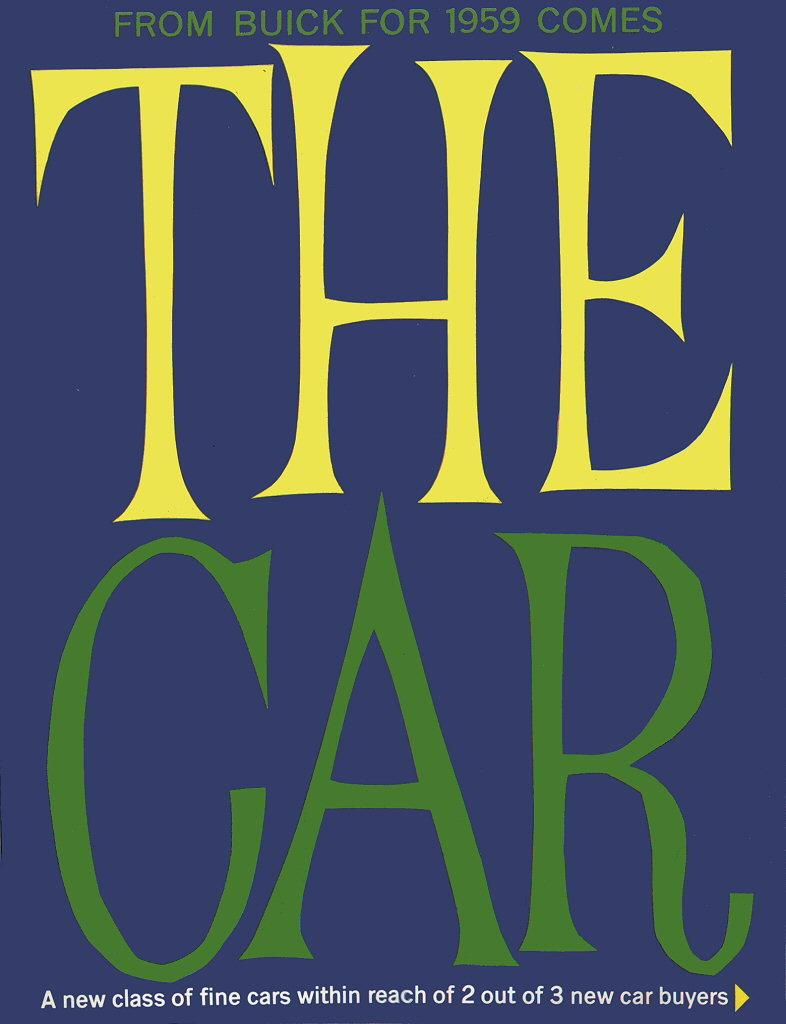<image>
Create a compact narrative representing the image presented. A vintage advertisement for the Buick car company. 